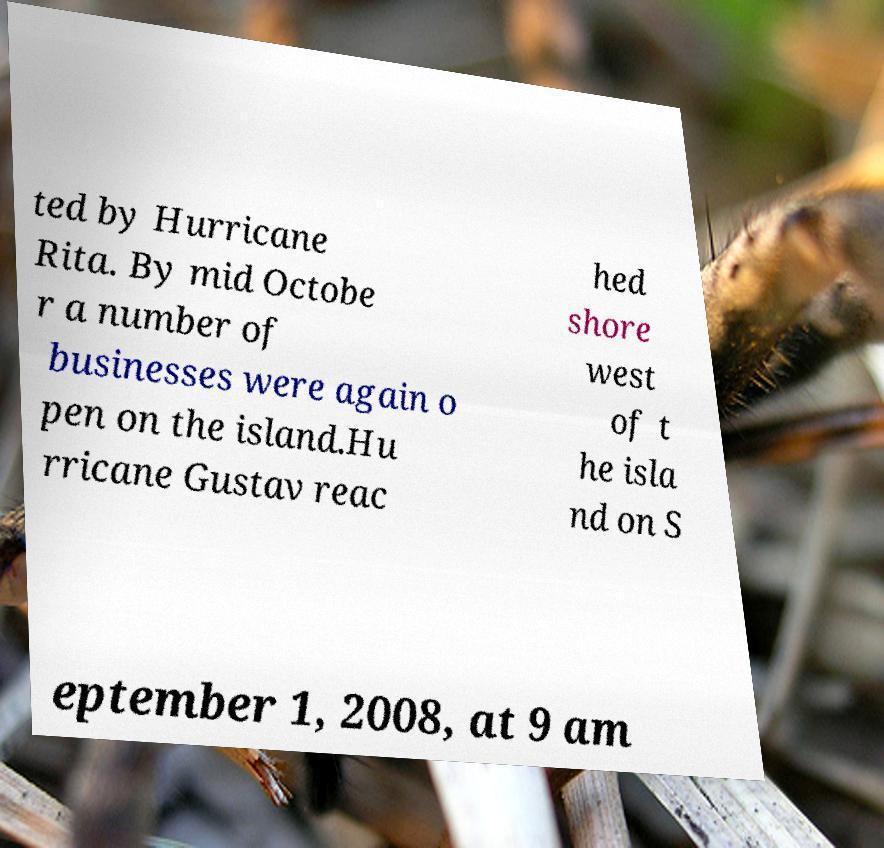There's text embedded in this image that I need extracted. Can you transcribe it verbatim? ted by Hurricane Rita. By mid Octobe r a number of businesses were again o pen on the island.Hu rricane Gustav reac hed shore west of t he isla nd on S eptember 1, 2008, at 9 am 